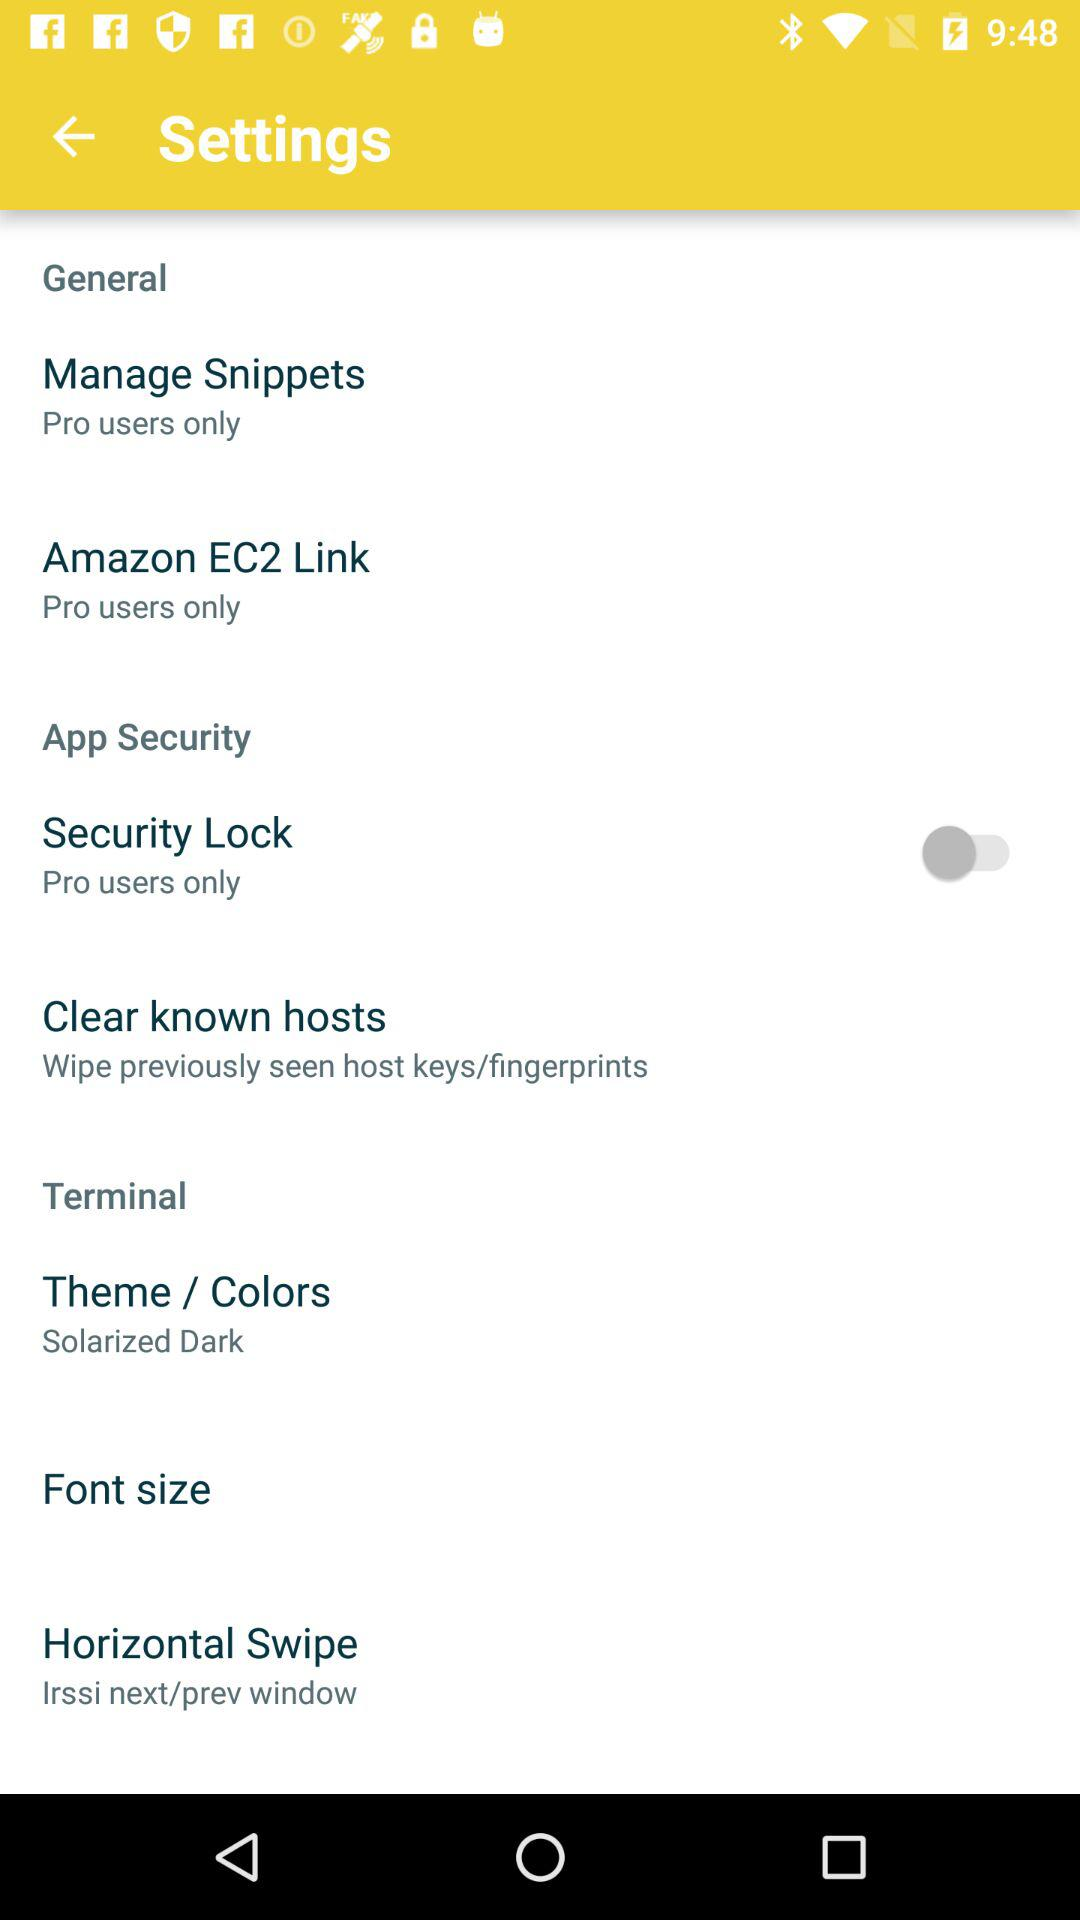What types of users can access Amazon EC2 Link? The types of users who can access Amazon EC2 Link are Pro users only. 